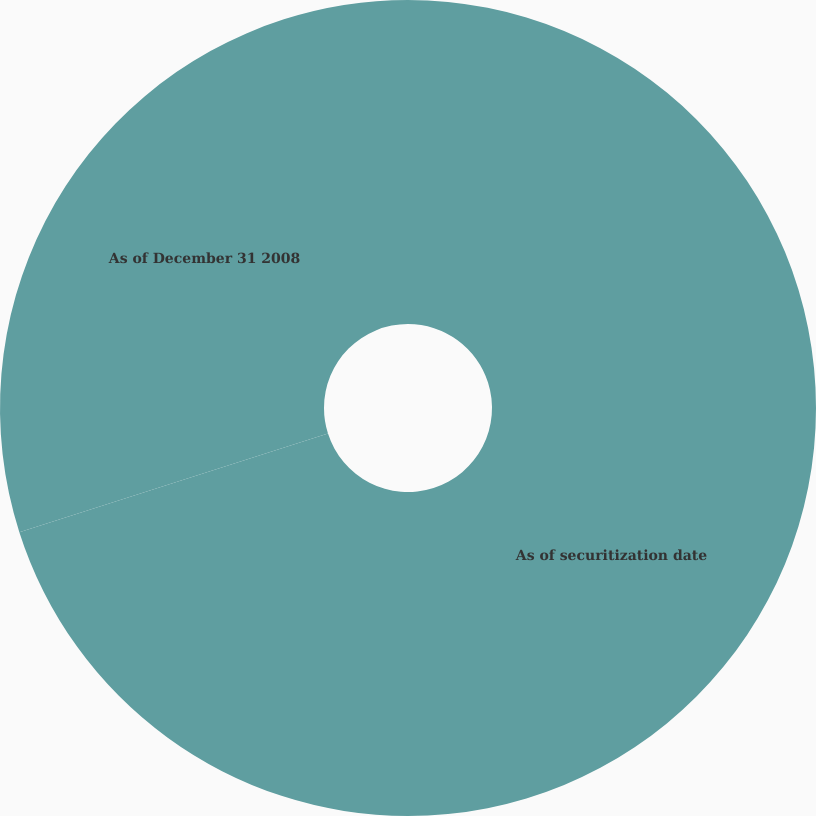Convert chart. <chart><loc_0><loc_0><loc_500><loc_500><pie_chart><fcel>As of securitization date<fcel>As of December 31 2008<nl><fcel>70.08%<fcel>29.92%<nl></chart> 